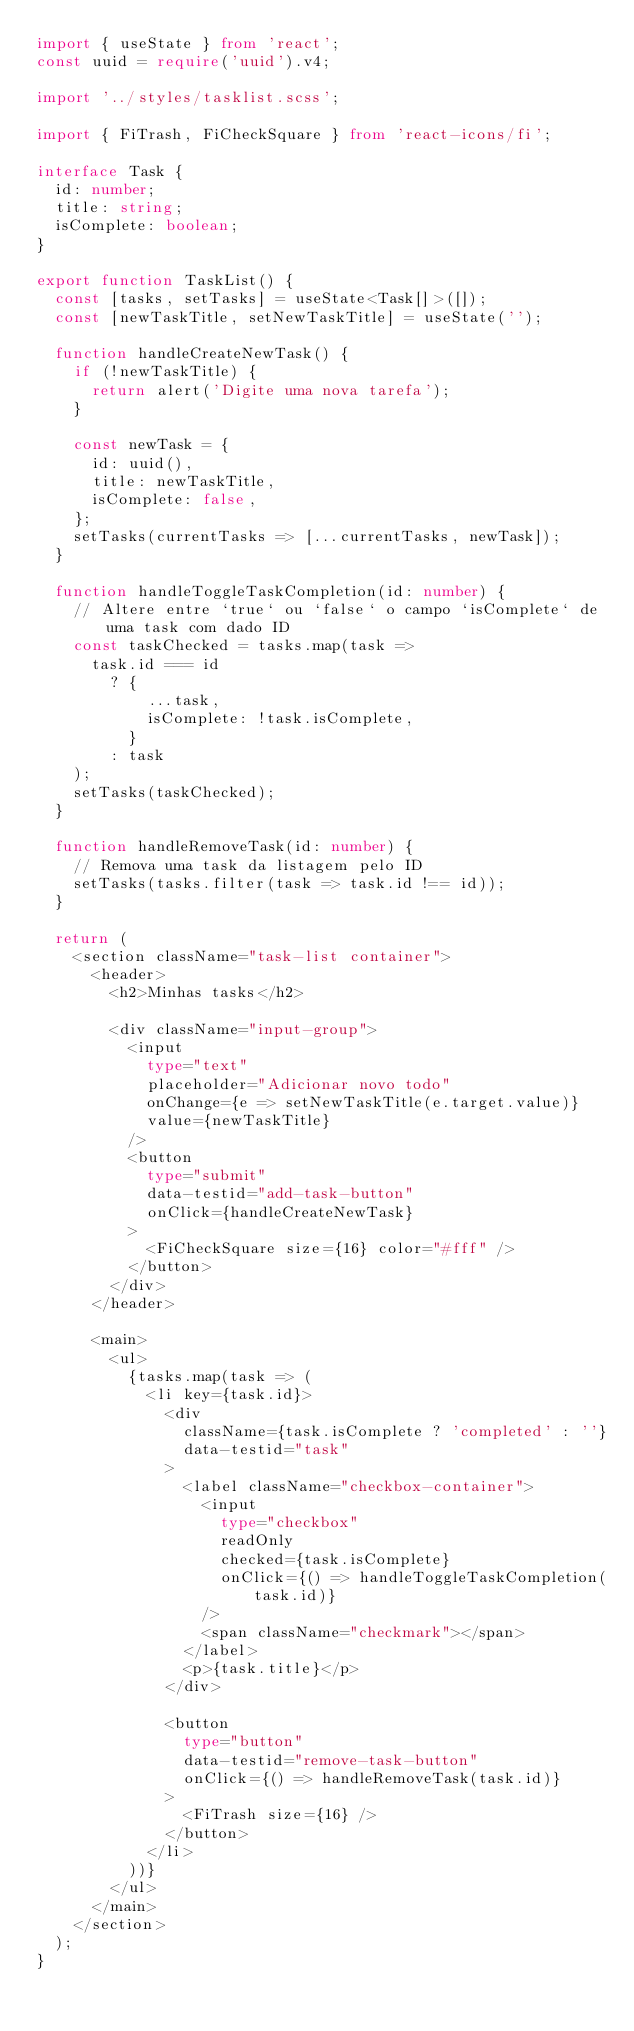<code> <loc_0><loc_0><loc_500><loc_500><_TypeScript_>import { useState } from 'react';
const uuid = require('uuid').v4;

import '../styles/tasklist.scss';

import { FiTrash, FiCheckSquare } from 'react-icons/fi';

interface Task {
  id: number;
  title: string;
  isComplete: boolean;
}

export function TaskList() {
  const [tasks, setTasks] = useState<Task[]>([]);
  const [newTaskTitle, setNewTaskTitle] = useState('');

  function handleCreateNewTask() {
    if (!newTaskTitle) {
      return alert('Digite uma nova tarefa');
    }

    const newTask = {
      id: uuid(),
      title: newTaskTitle,
      isComplete: false,
    };
    setTasks(currentTasks => [...currentTasks, newTask]);
  }

  function handleToggleTaskCompletion(id: number) {
    // Altere entre `true` ou `false` o campo `isComplete` de uma task com dado ID
    const taskChecked = tasks.map(task =>
      task.id === id
        ? {
            ...task,
            isComplete: !task.isComplete,
          }
        : task
    );
    setTasks(taskChecked);
  }

  function handleRemoveTask(id: number) {
    // Remova uma task da listagem pelo ID
    setTasks(tasks.filter(task => task.id !== id));
  }

  return (
    <section className="task-list container">
      <header>
        <h2>Minhas tasks</h2>

        <div className="input-group">
          <input
            type="text"
            placeholder="Adicionar novo todo"
            onChange={e => setNewTaskTitle(e.target.value)}
            value={newTaskTitle}
          />
          <button
            type="submit"
            data-testid="add-task-button"
            onClick={handleCreateNewTask}
          >
            <FiCheckSquare size={16} color="#fff" />
          </button>
        </div>
      </header>

      <main>
        <ul>
          {tasks.map(task => (
            <li key={task.id}>
              <div
                className={task.isComplete ? 'completed' : ''}
                data-testid="task"
              >
                <label className="checkbox-container">
                  <input
                    type="checkbox"
                    readOnly
                    checked={task.isComplete}
                    onClick={() => handleToggleTaskCompletion(task.id)}
                  />
                  <span className="checkmark"></span>
                </label>
                <p>{task.title}</p>
              </div>

              <button
                type="button"
                data-testid="remove-task-button"
                onClick={() => handleRemoveTask(task.id)}
              >
                <FiTrash size={16} />
              </button>
            </li>
          ))}
        </ul>
      </main>
    </section>
  );
}
</code> 